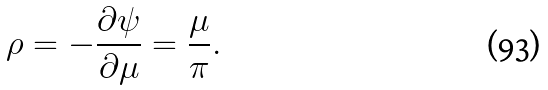Convert formula to latex. <formula><loc_0><loc_0><loc_500><loc_500>\rho = - \frac { \partial \psi } { \partial \mu } = \frac { \mu } { \pi } .</formula> 